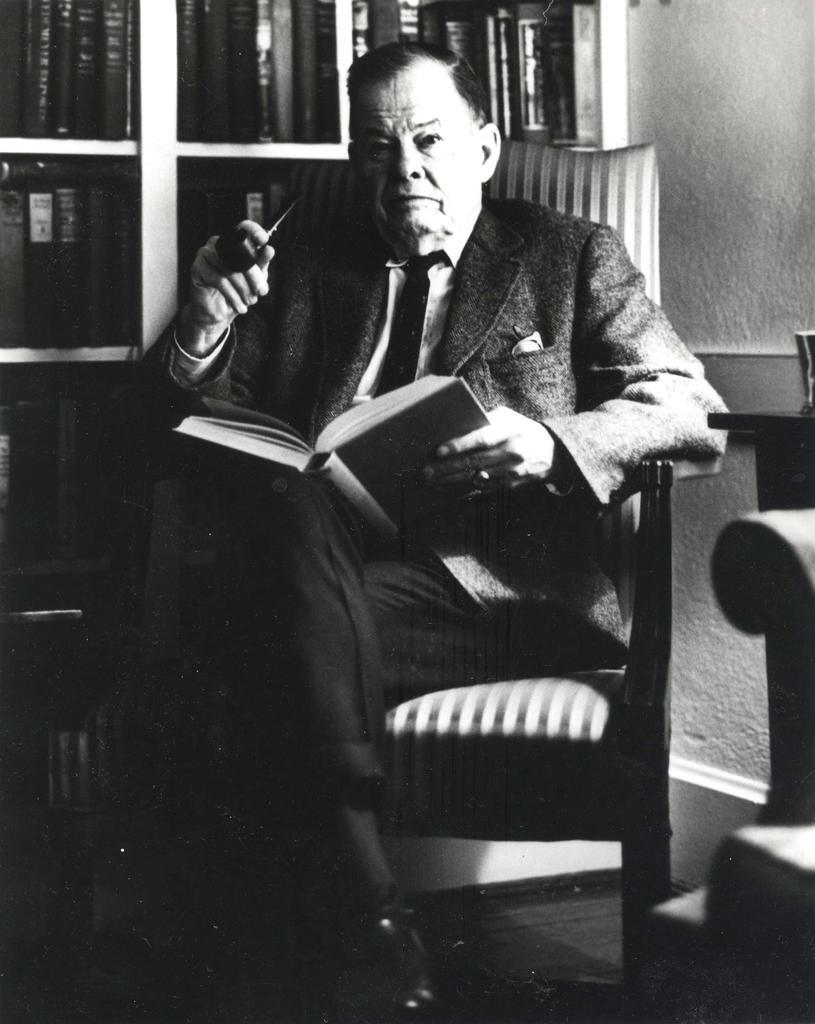What is the person in the image doing? The person is holding a book in the image. Where is the person sitting? The person is sitting on a chair in the image. What else can be seen in the image related to books? There is a cupboard with books in the image. What is visible in the background of the image? There is a wall in the image. How many snails can be seen crawling on the wall in the image? There are no snails visible in the image; only a person, a book, a chair, a cupboard with books, and a wall are present. 